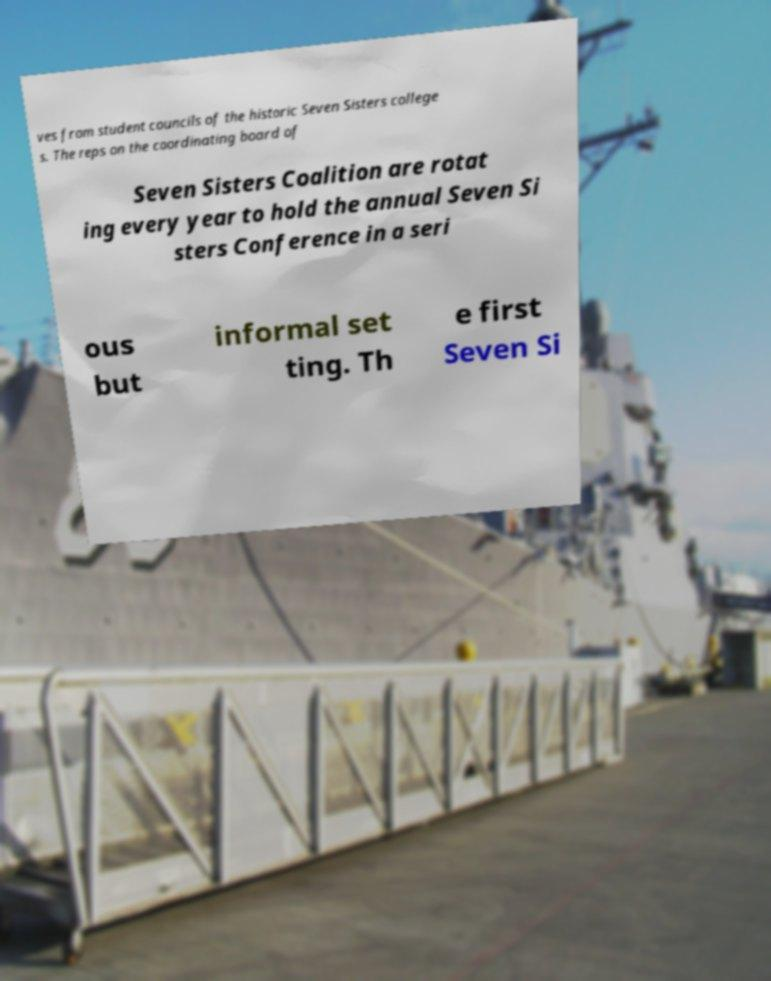Can you read and provide the text displayed in the image?This photo seems to have some interesting text. Can you extract and type it out for me? ves from student councils of the historic Seven Sisters college s. The reps on the coordinating board of Seven Sisters Coalition are rotat ing every year to hold the annual Seven Si sters Conference in a seri ous but informal set ting. Th e first Seven Si 